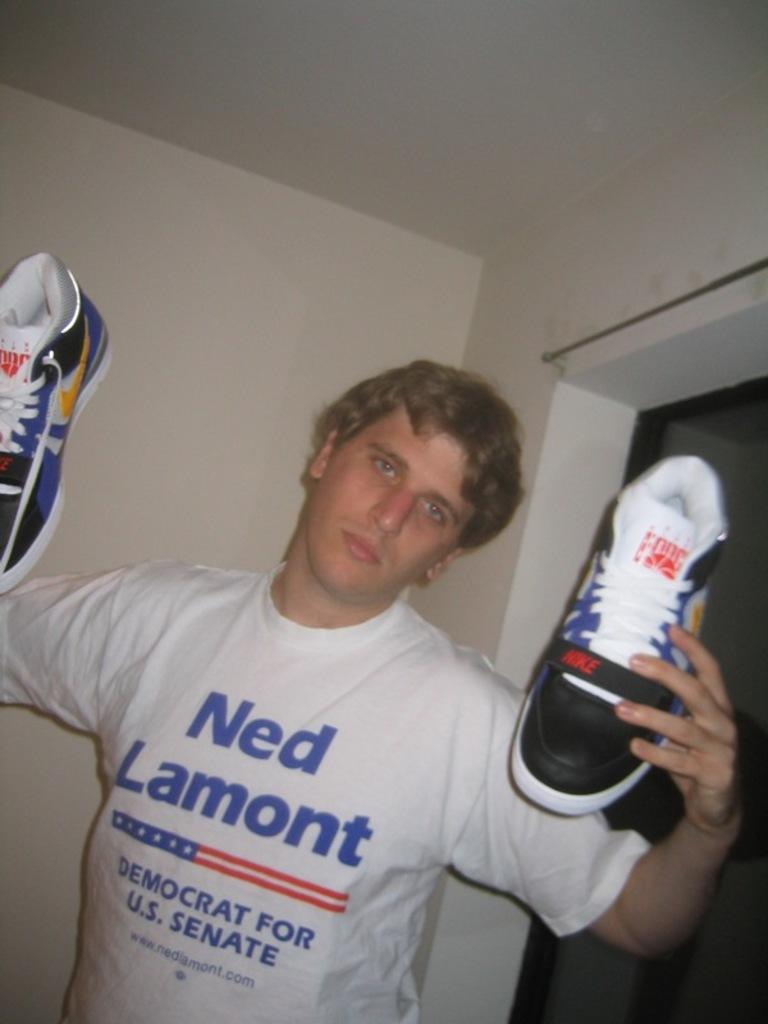<image>
Present a compact description of the photo's key features. a man with Ned Lamont on his shirt 